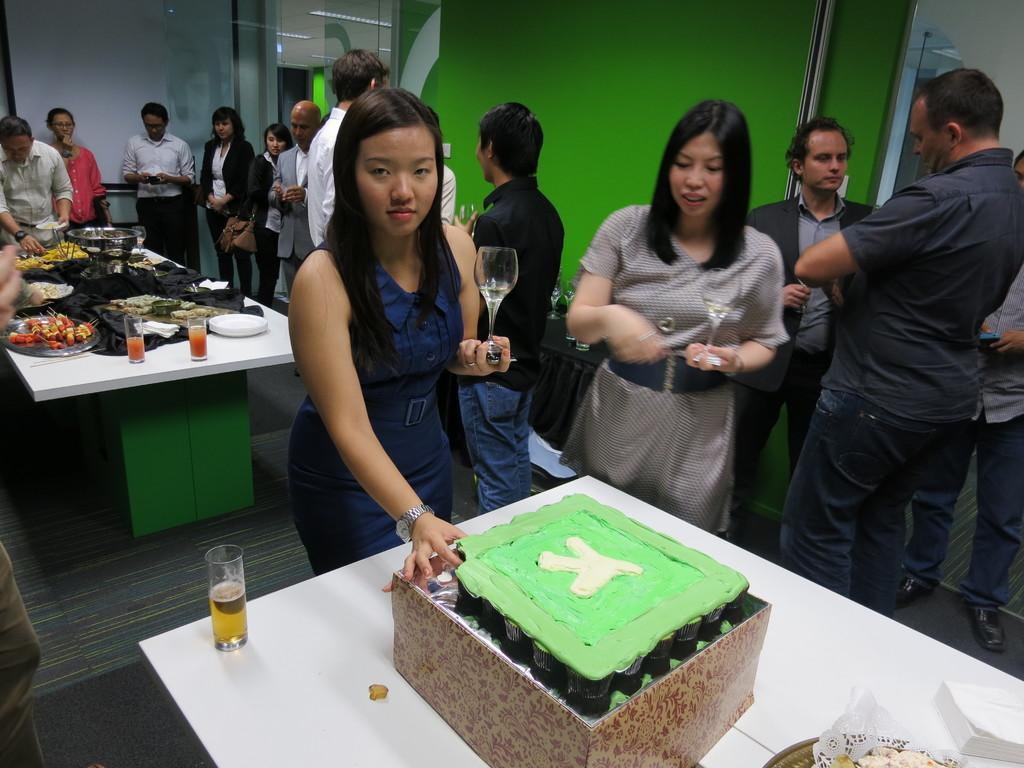What can you describe the people in the image? There are people standing in the image. What is on the table in the image? There is a cake on a table in the image. What type of coat is the cow wearing in the image? There is no cow or coat present in the image. What is the limit of the cake in the image? The image does not provide information about the size or limit of the cake. 